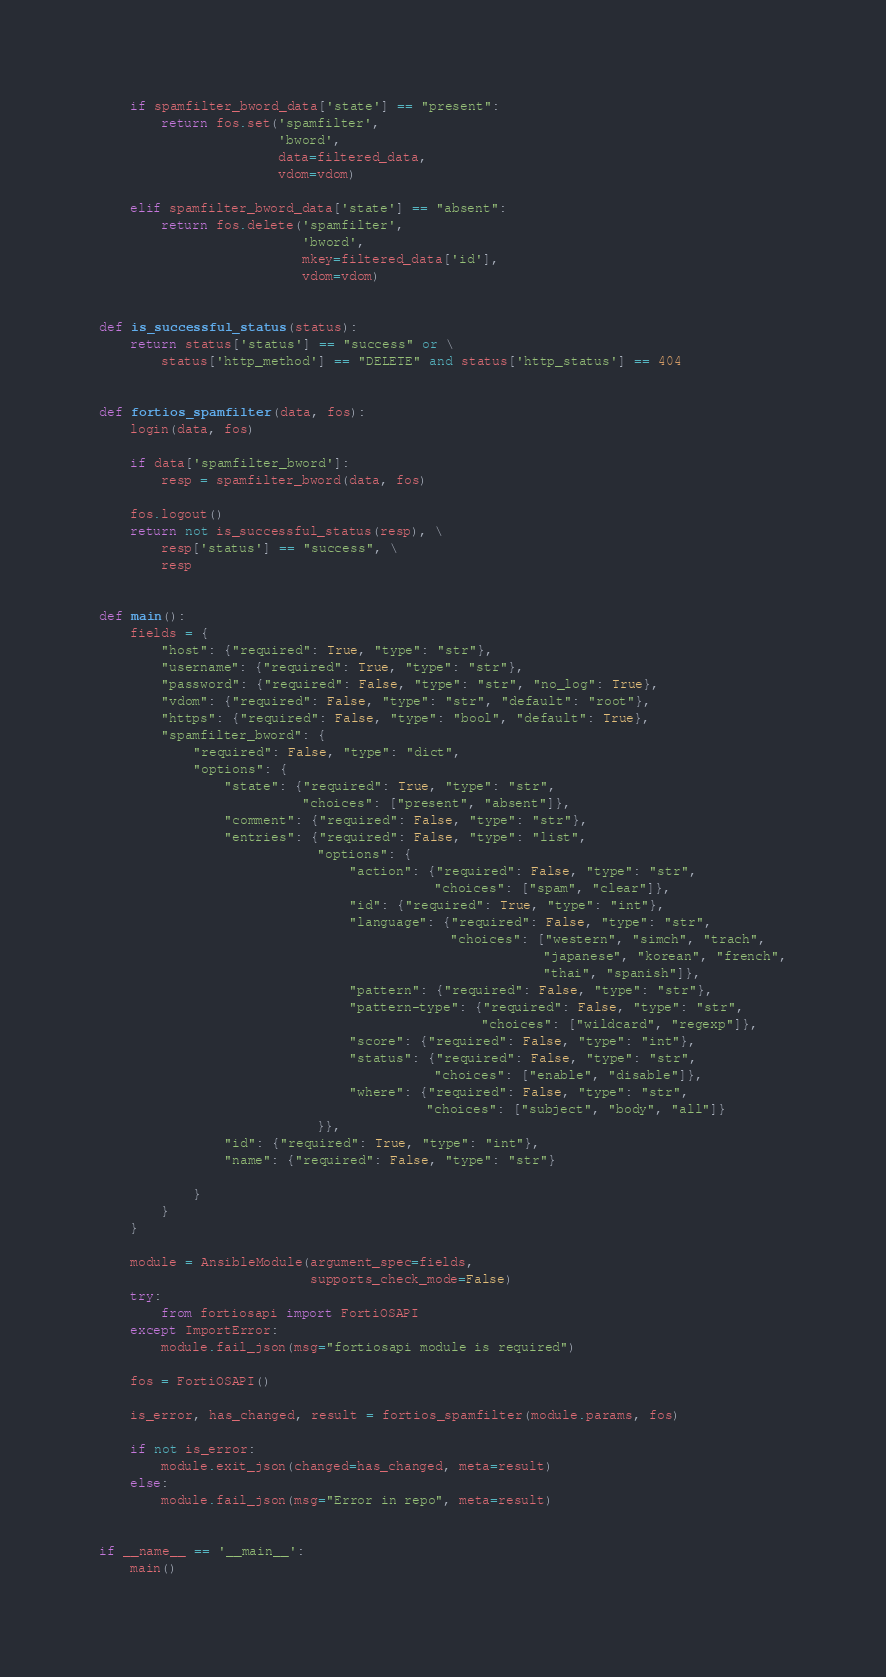Convert code to text. <code><loc_0><loc_0><loc_500><loc_500><_Python_>    if spamfilter_bword_data['state'] == "present":
        return fos.set('spamfilter',
                       'bword',
                       data=filtered_data,
                       vdom=vdom)

    elif spamfilter_bword_data['state'] == "absent":
        return fos.delete('spamfilter',
                          'bword',
                          mkey=filtered_data['id'],
                          vdom=vdom)


def is_successful_status(status):
    return status['status'] == "success" or \
        status['http_method'] == "DELETE" and status['http_status'] == 404


def fortios_spamfilter(data, fos):
    login(data, fos)

    if data['spamfilter_bword']:
        resp = spamfilter_bword(data, fos)

    fos.logout()
    return not is_successful_status(resp), \
        resp['status'] == "success", \
        resp


def main():
    fields = {
        "host": {"required": True, "type": "str"},
        "username": {"required": True, "type": "str"},
        "password": {"required": False, "type": "str", "no_log": True},
        "vdom": {"required": False, "type": "str", "default": "root"},
        "https": {"required": False, "type": "bool", "default": True},
        "spamfilter_bword": {
            "required": False, "type": "dict",
            "options": {
                "state": {"required": True, "type": "str",
                          "choices": ["present", "absent"]},
                "comment": {"required": False, "type": "str"},
                "entries": {"required": False, "type": "list",
                            "options": {
                                "action": {"required": False, "type": "str",
                                           "choices": ["spam", "clear"]},
                                "id": {"required": True, "type": "int"},
                                "language": {"required": False, "type": "str",
                                             "choices": ["western", "simch", "trach",
                                                         "japanese", "korean", "french",
                                                         "thai", "spanish"]},
                                "pattern": {"required": False, "type": "str"},
                                "pattern-type": {"required": False, "type": "str",
                                                 "choices": ["wildcard", "regexp"]},
                                "score": {"required": False, "type": "int"},
                                "status": {"required": False, "type": "str",
                                           "choices": ["enable", "disable"]},
                                "where": {"required": False, "type": "str",
                                          "choices": ["subject", "body", "all"]}
                            }},
                "id": {"required": True, "type": "int"},
                "name": {"required": False, "type": "str"}

            }
        }
    }

    module = AnsibleModule(argument_spec=fields,
                           supports_check_mode=False)
    try:
        from fortiosapi import FortiOSAPI
    except ImportError:
        module.fail_json(msg="fortiosapi module is required")

    fos = FortiOSAPI()

    is_error, has_changed, result = fortios_spamfilter(module.params, fos)

    if not is_error:
        module.exit_json(changed=has_changed, meta=result)
    else:
        module.fail_json(msg="Error in repo", meta=result)


if __name__ == '__main__':
    main()
</code> 